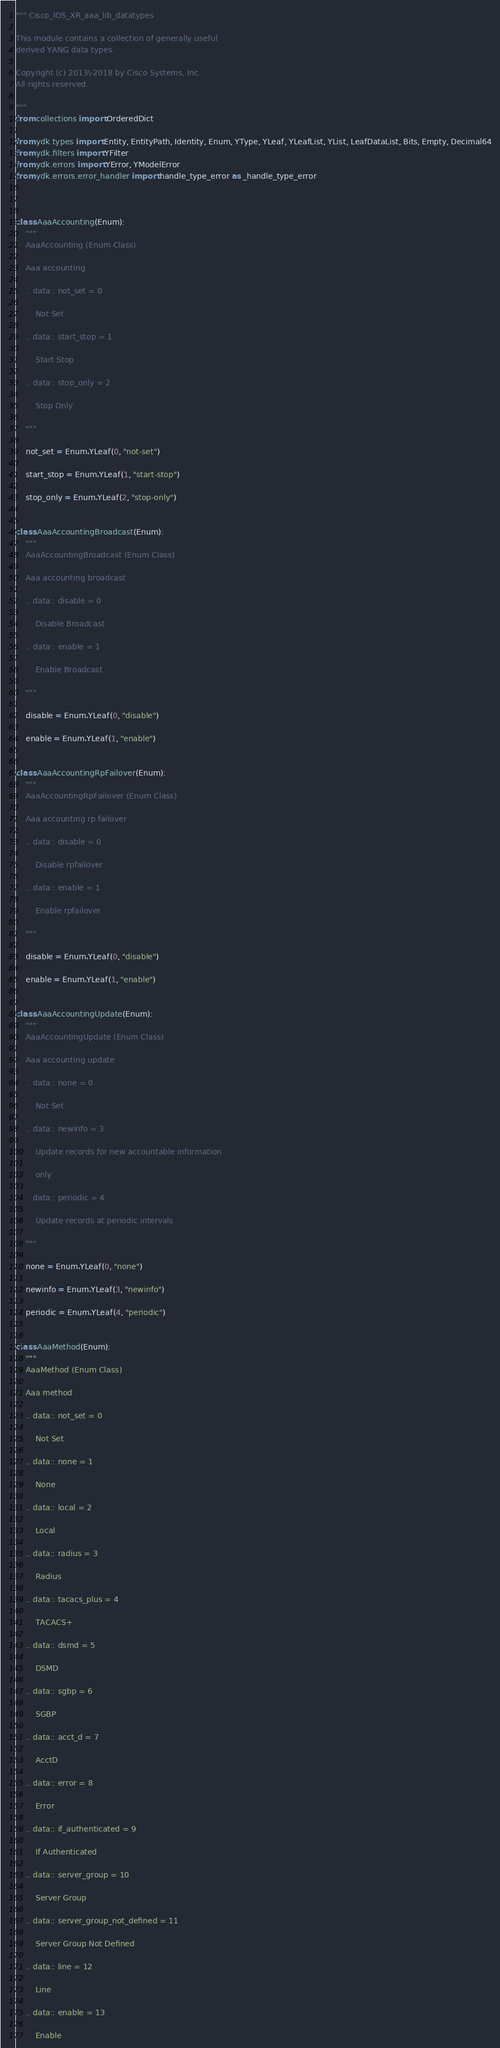Convert code to text. <code><loc_0><loc_0><loc_500><loc_500><_Python_>""" Cisco_IOS_XR_aaa_lib_datatypes 

This module contains a collection of generally useful
derived YANG data types.

Copyright (c) 2013\-2018 by Cisco Systems, Inc.
All rights reserved.

"""
from collections import OrderedDict

from ydk.types import Entity, EntityPath, Identity, Enum, YType, YLeaf, YLeafList, YList, LeafDataList, Bits, Empty, Decimal64
from ydk.filters import YFilter
from ydk.errors import YError, YModelError
from ydk.errors.error_handler import handle_type_error as _handle_type_error



class AaaAccounting(Enum):
    """
    AaaAccounting (Enum Class)

    Aaa accounting

    .. data:: not_set = 0

    	Not Set

    .. data:: start_stop = 1

    	Start Stop

    .. data:: stop_only = 2

    	Stop Only

    """

    not_set = Enum.YLeaf(0, "not-set")

    start_stop = Enum.YLeaf(1, "start-stop")

    stop_only = Enum.YLeaf(2, "stop-only")


class AaaAccountingBroadcast(Enum):
    """
    AaaAccountingBroadcast (Enum Class)

    Aaa accounting broadcast

    .. data:: disable = 0

    	Disable Broadcast

    .. data:: enable = 1

    	Enable Broadcast

    """

    disable = Enum.YLeaf(0, "disable")

    enable = Enum.YLeaf(1, "enable")


class AaaAccountingRpFailover(Enum):
    """
    AaaAccountingRpFailover (Enum Class)

    Aaa accounting rp failover

    .. data:: disable = 0

    	Disable rpfailover

    .. data:: enable = 1

    	Enable rpfailover

    """

    disable = Enum.YLeaf(0, "disable")

    enable = Enum.YLeaf(1, "enable")


class AaaAccountingUpdate(Enum):
    """
    AaaAccountingUpdate (Enum Class)

    Aaa accounting update

    .. data:: none = 0

    	Not Set

    .. data:: newinfo = 3

    	Update records for new accountable information

    	only

    .. data:: periodic = 4

    	Update records at periodic intervals

    """

    none = Enum.YLeaf(0, "none")

    newinfo = Enum.YLeaf(3, "newinfo")

    periodic = Enum.YLeaf(4, "periodic")


class AaaMethod(Enum):
    """
    AaaMethod (Enum Class)

    Aaa method

    .. data:: not_set = 0

    	Not Set

    .. data:: none = 1

    	None

    .. data:: local = 2

    	Local

    .. data:: radius = 3

    	Radius

    .. data:: tacacs_plus = 4

    	TACACS+

    .. data:: dsmd = 5

    	DSMD

    .. data:: sgbp = 6

    	SGBP

    .. data:: acct_d = 7

    	AcctD

    .. data:: error = 8

    	Error

    .. data:: if_authenticated = 9

    	If Authenticated

    .. data:: server_group = 10

    	Server Group

    .. data:: server_group_not_defined = 11

    	Server Group Not Defined

    .. data:: line = 12

    	Line

    .. data:: enable = 13

    	Enable
</code> 